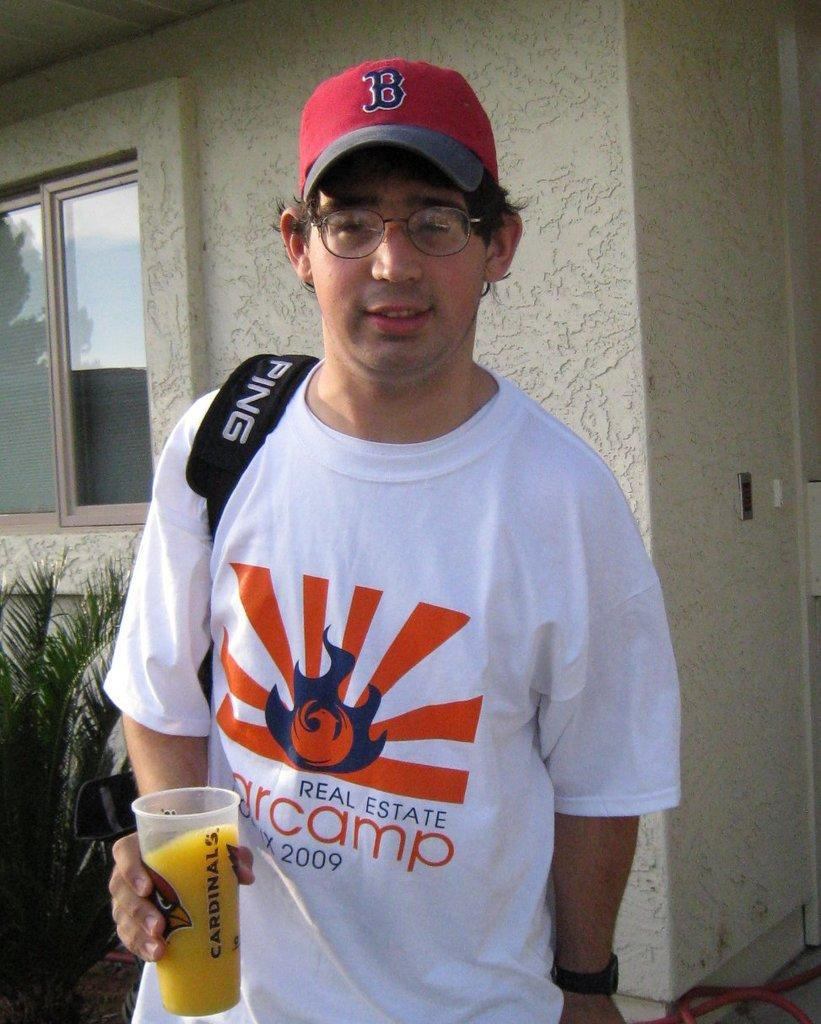<image>
Provide a brief description of the given image. A man is holding a glass of juice in a Cardinals cup and wearing a real estate t-shirt. 